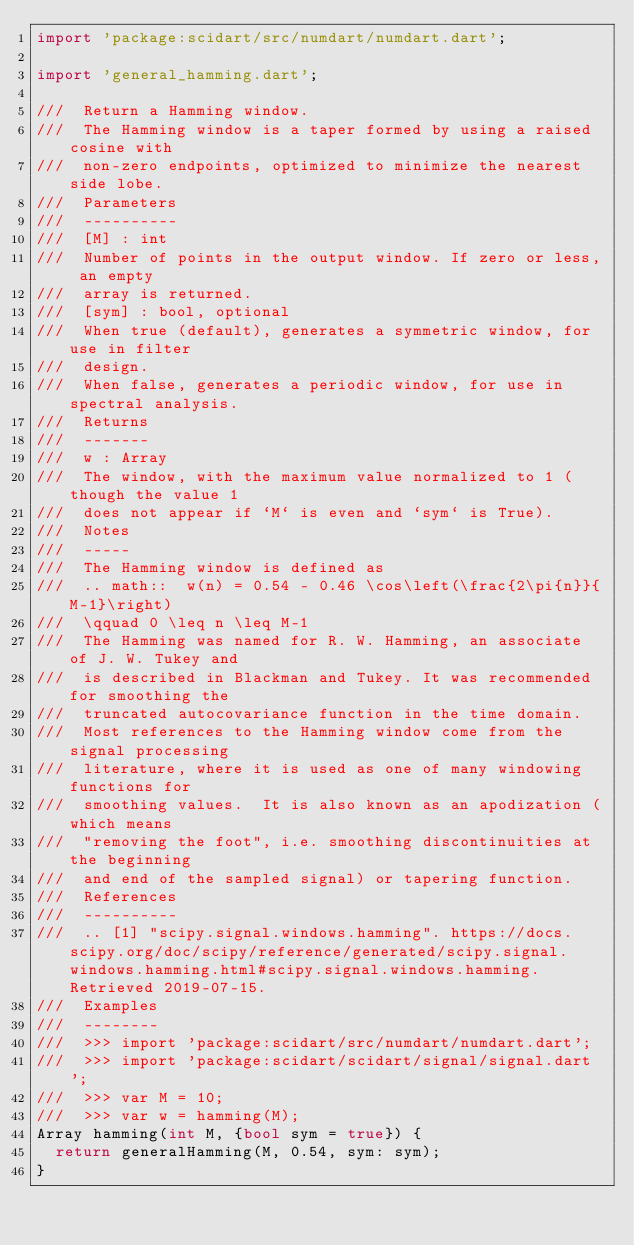Convert code to text. <code><loc_0><loc_0><loc_500><loc_500><_Dart_>import 'package:scidart/src/numdart/numdart.dart';

import 'general_hamming.dart';

///  Return a Hamming window.
///  The Hamming window is a taper formed by using a raised cosine with
///  non-zero endpoints, optimized to minimize the nearest side lobe.
///  Parameters
///  ----------
///  [M] : int
///  Number of points in the output window. If zero or less, an empty
///  array is returned.
///  [sym] : bool, optional
///  When true (default), generates a symmetric window, for use in filter
///  design.
///  When false, generates a periodic window, for use in spectral analysis.
///  Returns
///  -------
///  w : Array
///  The window, with the maximum value normalized to 1 (though the value 1
///  does not appear if `M` is even and `sym` is True).
///  Notes
///  -----
///  The Hamming window is defined as
///  .. math::  w(n) = 0.54 - 0.46 \cos\left(\frac{2\pi{n}}{M-1}\right)
///  \qquad 0 \leq n \leq M-1
///  The Hamming was named for R. W. Hamming, an associate of J. W. Tukey and
///  is described in Blackman and Tukey. It was recommended for smoothing the
///  truncated autocovariance function in the time domain.
///  Most references to the Hamming window come from the signal processing
///  literature, where it is used as one of many windowing functions for
///  smoothing values.  It is also known as an apodization (which means
///  "removing the foot", i.e. smoothing discontinuities at the beginning
///  and end of the sampled signal) or tapering function.
///  References
///  ----------
///  .. [1] "scipy.signal.windows.hamming". https://docs.scipy.org/doc/scipy/reference/generated/scipy.signal.windows.hamming.html#scipy.signal.windows.hamming. Retrieved 2019-07-15.
///  Examples
///  --------
///  >>> import 'package:scidart/src/numdart/numdart.dart';
///  >>> import 'package:scidart/scidart/signal/signal.dart';
///  >>> var M = 10;
///  >>> var w = hamming(M);
Array hamming(int M, {bool sym = true}) {
  return generalHamming(M, 0.54, sym: sym);
}</code> 